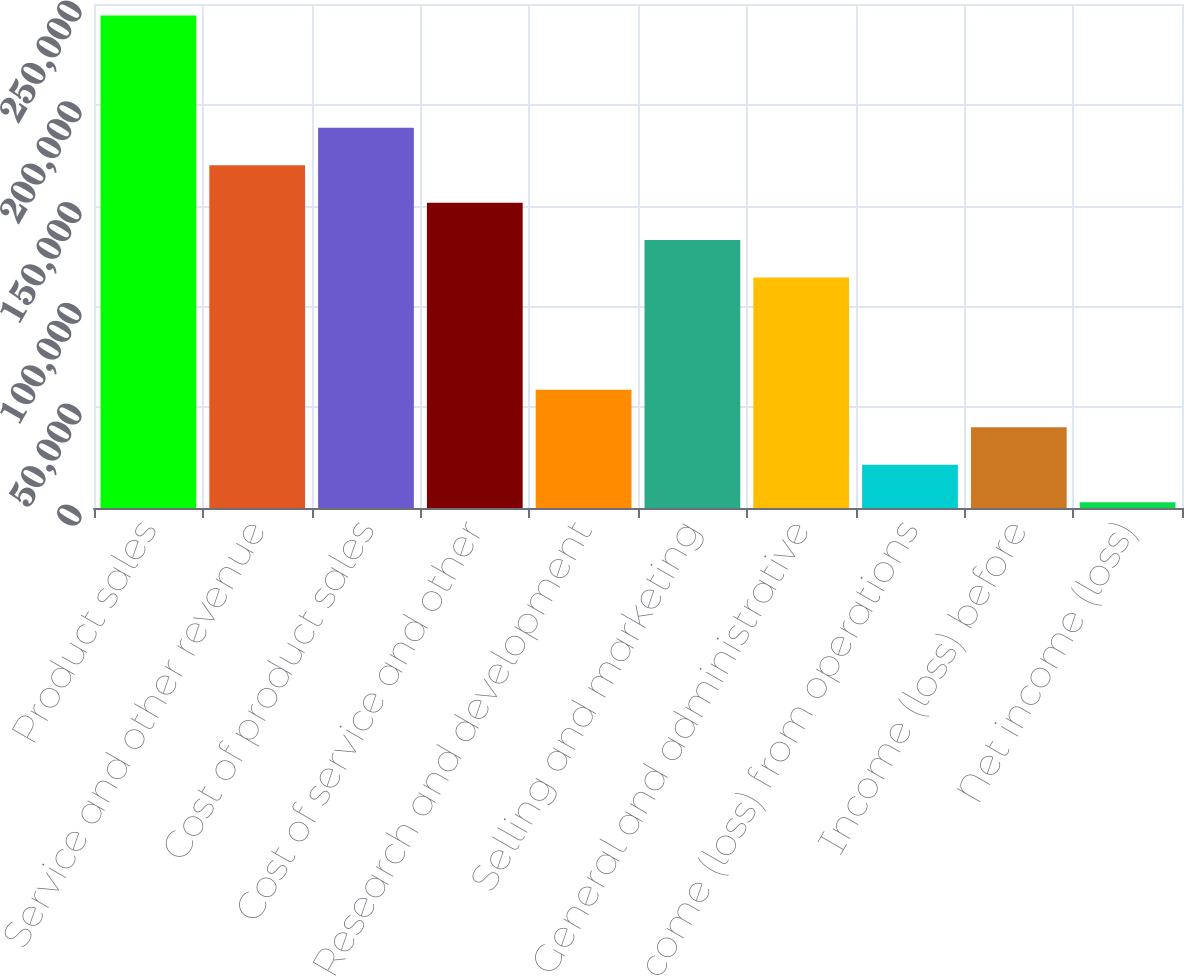Convert chart to OTSL. <chart><loc_0><loc_0><loc_500><loc_500><bar_chart><fcel>Product sales<fcel>Service and other revenue<fcel>Cost of product sales<fcel>Cost of service and other<fcel>Research and development<fcel>Selling and marketing<fcel>General and administrative<fcel>Income (loss) from operations<fcel>Income (loss) before<fcel>Net income (loss)<nl><fcel>244319<fcel>170031<fcel>188603<fcel>151459<fcel>58598.3<fcel>132887<fcel>114315<fcel>21454.1<fcel>40026.2<fcel>2882<nl></chart> 